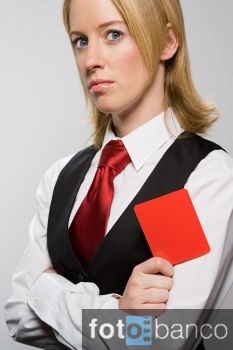Describe the objects in this image and their specific colors. I can see people in lightgray, black, tan, and gray tones and tie in lightgray, maroon, brown, and black tones in this image. 